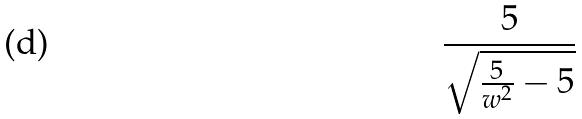<formula> <loc_0><loc_0><loc_500><loc_500>\frac { 5 } { \sqrt { \frac { 5 } { w ^ { 2 } } - 5 } }</formula> 